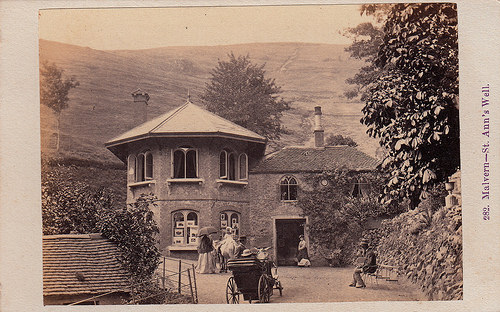<image>
Is there a carriage under the window? No. The carriage is not positioned under the window. The vertical relationship between these objects is different. 